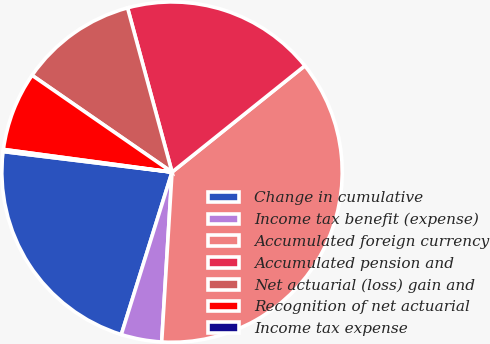Convert chart. <chart><loc_0><loc_0><loc_500><loc_500><pie_chart><fcel>Change in cumulative<fcel>Income tax benefit (expense)<fcel>Accumulated foreign currency<fcel>Accumulated pension and<fcel>Net actuarial (loss) gain and<fcel>Recognition of net actuarial<fcel>Income tax expense<nl><fcel>22.11%<fcel>3.85%<fcel>36.71%<fcel>18.46%<fcel>11.16%<fcel>7.5%<fcel>0.2%<nl></chart> 